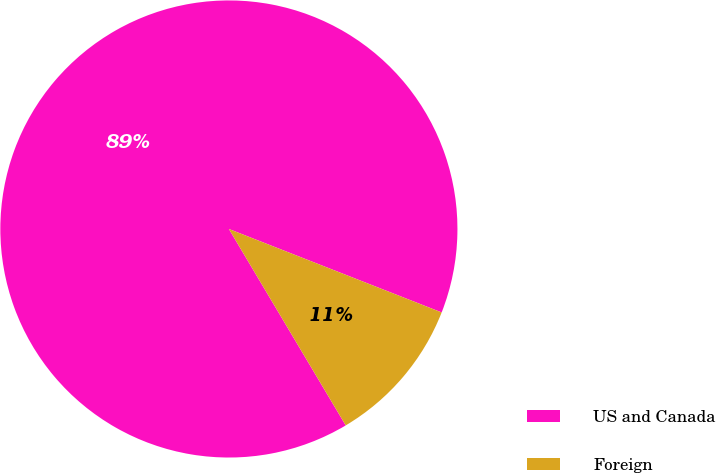Convert chart to OTSL. <chart><loc_0><loc_0><loc_500><loc_500><pie_chart><fcel>US and Canada<fcel>Foreign<nl><fcel>89.49%<fcel>10.51%<nl></chart> 